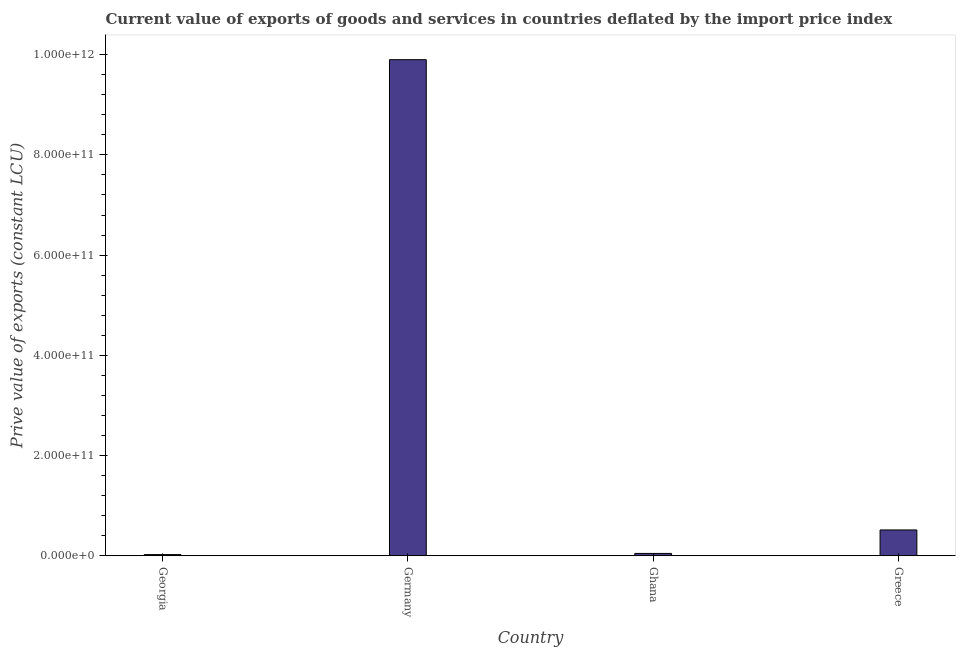Does the graph contain grids?
Ensure brevity in your answer.  No. What is the title of the graph?
Ensure brevity in your answer.  Current value of exports of goods and services in countries deflated by the import price index. What is the label or title of the X-axis?
Your answer should be compact. Country. What is the label or title of the Y-axis?
Your answer should be very brief. Prive value of exports (constant LCU). What is the price value of exports in Ghana?
Make the answer very short. 4.71e+09. Across all countries, what is the maximum price value of exports?
Your response must be concise. 9.90e+11. Across all countries, what is the minimum price value of exports?
Provide a short and direct response. 2.36e+09. In which country was the price value of exports minimum?
Give a very brief answer. Georgia. What is the sum of the price value of exports?
Give a very brief answer. 1.05e+12. What is the difference between the price value of exports in Georgia and Greece?
Offer a very short reply. -4.92e+1. What is the average price value of exports per country?
Your response must be concise. 2.62e+11. What is the median price value of exports?
Make the answer very short. 2.81e+1. In how many countries, is the price value of exports greater than 160000000000 LCU?
Make the answer very short. 1. What is the ratio of the price value of exports in Germany to that in Greece?
Your answer should be very brief. 19.19. Is the price value of exports in Georgia less than that in Germany?
Provide a short and direct response. Yes. Is the difference between the price value of exports in Germany and Greece greater than the difference between any two countries?
Your answer should be compact. No. What is the difference between the highest and the second highest price value of exports?
Keep it short and to the point. 9.38e+11. What is the difference between the highest and the lowest price value of exports?
Provide a succinct answer. 9.88e+11. Are all the bars in the graph horizontal?
Make the answer very short. No. What is the difference between two consecutive major ticks on the Y-axis?
Your answer should be compact. 2.00e+11. Are the values on the major ticks of Y-axis written in scientific E-notation?
Your response must be concise. Yes. What is the Prive value of exports (constant LCU) in Georgia?
Keep it short and to the point. 2.36e+09. What is the Prive value of exports (constant LCU) of Germany?
Ensure brevity in your answer.  9.90e+11. What is the Prive value of exports (constant LCU) of Ghana?
Keep it short and to the point. 4.71e+09. What is the Prive value of exports (constant LCU) of Greece?
Your answer should be very brief. 5.16e+1. What is the difference between the Prive value of exports (constant LCU) in Georgia and Germany?
Offer a very short reply. -9.88e+11. What is the difference between the Prive value of exports (constant LCU) in Georgia and Ghana?
Your answer should be compact. -2.35e+09. What is the difference between the Prive value of exports (constant LCU) in Georgia and Greece?
Keep it short and to the point. -4.92e+1. What is the difference between the Prive value of exports (constant LCU) in Germany and Ghana?
Offer a very short reply. 9.85e+11. What is the difference between the Prive value of exports (constant LCU) in Germany and Greece?
Your answer should be compact. 9.38e+11. What is the difference between the Prive value of exports (constant LCU) in Ghana and Greece?
Your response must be concise. -4.69e+1. What is the ratio of the Prive value of exports (constant LCU) in Georgia to that in Germany?
Give a very brief answer. 0. What is the ratio of the Prive value of exports (constant LCU) in Georgia to that in Ghana?
Provide a succinct answer. 0.5. What is the ratio of the Prive value of exports (constant LCU) in Georgia to that in Greece?
Your answer should be compact. 0.05. What is the ratio of the Prive value of exports (constant LCU) in Germany to that in Ghana?
Make the answer very short. 210.09. What is the ratio of the Prive value of exports (constant LCU) in Germany to that in Greece?
Provide a succinct answer. 19.19. What is the ratio of the Prive value of exports (constant LCU) in Ghana to that in Greece?
Provide a short and direct response. 0.09. 